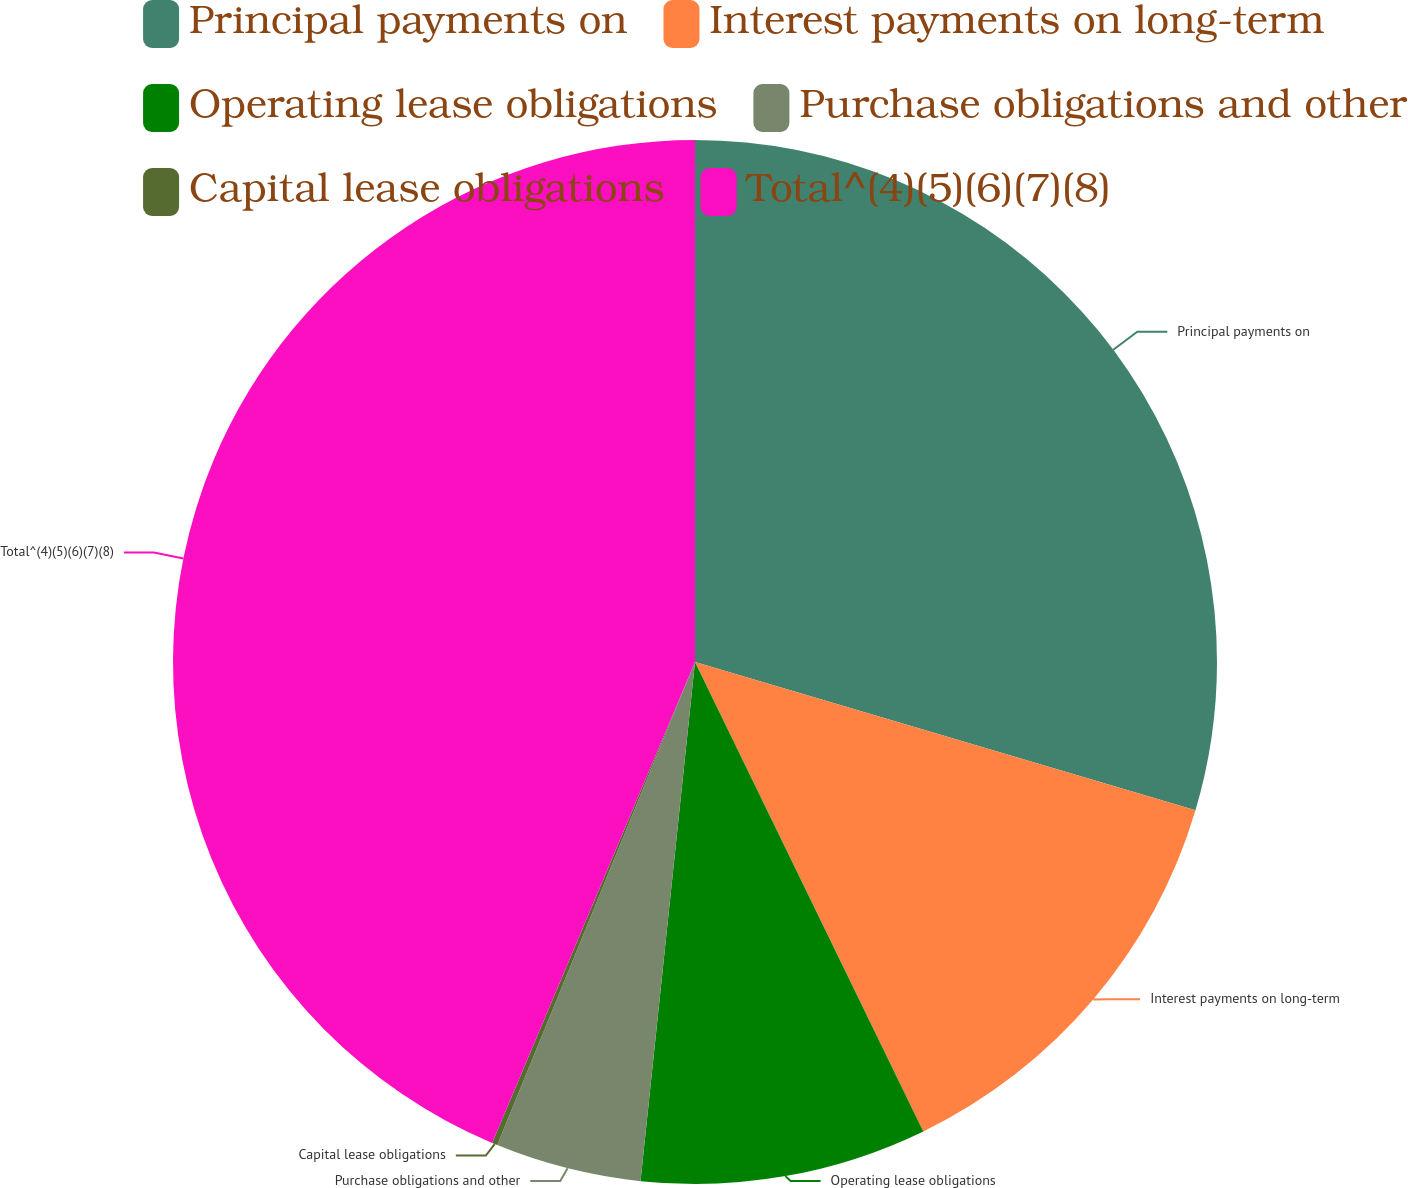Convert chart. <chart><loc_0><loc_0><loc_500><loc_500><pie_chart><fcel>Principal payments on<fcel>Interest payments on long-term<fcel>Operating lease obligations<fcel>Purchase obligations and other<fcel>Capital lease obligations<fcel>Total^(4)(5)(6)(7)(8)<nl><fcel>29.59%<fcel>13.21%<fcel>8.87%<fcel>4.52%<fcel>0.17%<fcel>43.65%<nl></chart> 